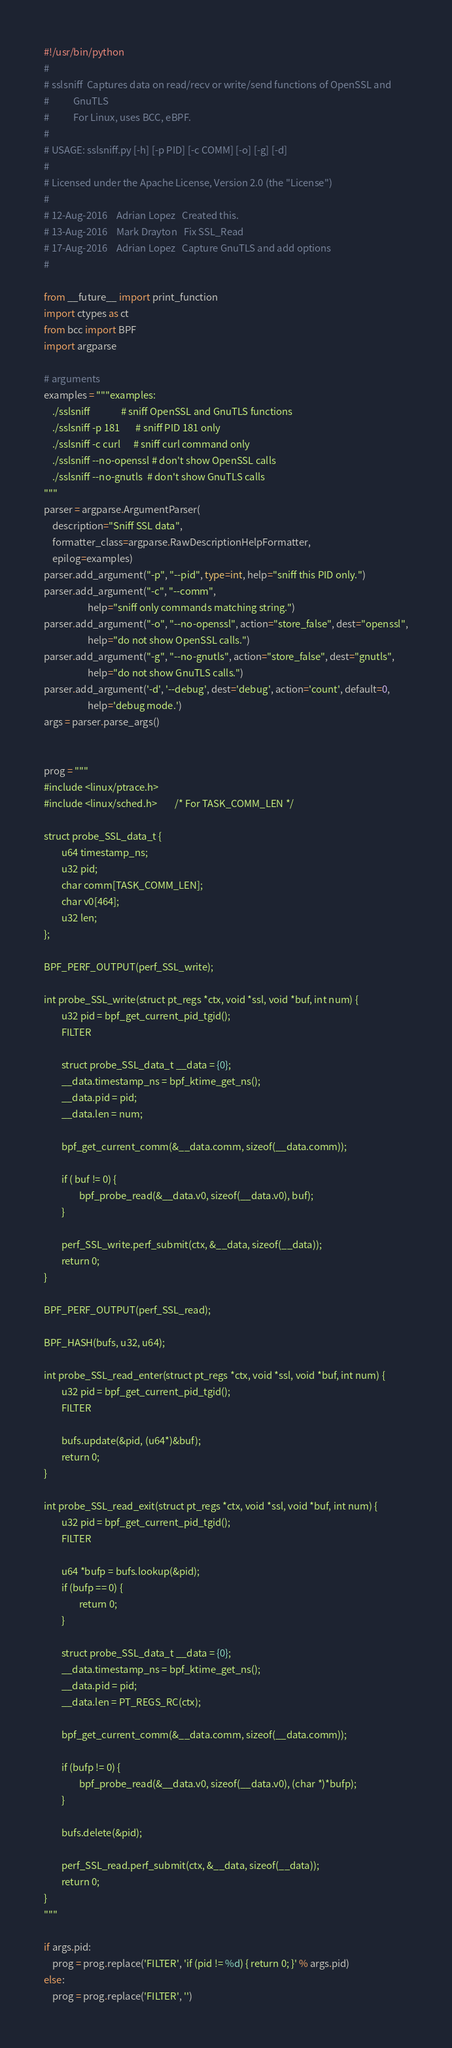<code> <loc_0><loc_0><loc_500><loc_500><_Python_>#!/usr/bin/python
#
# sslsniff  Captures data on read/recv or write/send functions of OpenSSL and
#           GnuTLS
#           For Linux, uses BCC, eBPF.
#
# USAGE: sslsniff.py [-h] [-p PID] [-c COMM] [-o] [-g] [-d]
#
# Licensed under the Apache License, Version 2.0 (the "License")
#
# 12-Aug-2016    Adrian Lopez   Created this.
# 13-Aug-2016    Mark Drayton   Fix SSL_Read
# 17-Aug-2016    Adrian Lopez   Capture GnuTLS and add options
#

from __future__ import print_function
import ctypes as ct
from bcc import BPF
import argparse

# arguments
examples = """examples:
    ./sslsniff              # sniff OpenSSL and GnuTLS functions
    ./sslsniff -p 181       # sniff PID 181 only
    ./sslsniff -c curl      # sniff curl command only
    ./sslsniff --no-openssl # don't show OpenSSL calls
    ./sslsniff --no-gnutls  # don't show GnuTLS calls
"""
parser = argparse.ArgumentParser(
    description="Sniff SSL data",
    formatter_class=argparse.RawDescriptionHelpFormatter,
    epilog=examples)
parser.add_argument("-p", "--pid", type=int, help="sniff this PID only.")
parser.add_argument("-c", "--comm",
                    help="sniff only commands matching string.")
parser.add_argument("-o", "--no-openssl", action="store_false", dest="openssl",
                    help="do not show OpenSSL calls.")
parser.add_argument("-g", "--no-gnutls", action="store_false", dest="gnutls",
                    help="do not show GnuTLS calls.")
parser.add_argument('-d', '--debug', dest='debug', action='count', default=0,
                    help='debug mode.')
args = parser.parse_args()


prog = """
#include <linux/ptrace.h>
#include <linux/sched.h>        /* For TASK_COMM_LEN */

struct probe_SSL_data_t {
        u64 timestamp_ns;
        u32 pid;
        char comm[TASK_COMM_LEN];
        char v0[464];
        u32 len;
};

BPF_PERF_OUTPUT(perf_SSL_write);

int probe_SSL_write(struct pt_regs *ctx, void *ssl, void *buf, int num) {
        u32 pid = bpf_get_current_pid_tgid();
        FILTER

        struct probe_SSL_data_t __data = {0};
        __data.timestamp_ns = bpf_ktime_get_ns();
        __data.pid = pid;
        __data.len = num;

        bpf_get_current_comm(&__data.comm, sizeof(__data.comm));

        if ( buf != 0) {
                bpf_probe_read(&__data.v0, sizeof(__data.v0), buf);
        }

        perf_SSL_write.perf_submit(ctx, &__data, sizeof(__data));
        return 0;
}

BPF_PERF_OUTPUT(perf_SSL_read);

BPF_HASH(bufs, u32, u64);

int probe_SSL_read_enter(struct pt_regs *ctx, void *ssl, void *buf, int num) {
        u32 pid = bpf_get_current_pid_tgid();
        FILTER

        bufs.update(&pid, (u64*)&buf);
        return 0;
}

int probe_SSL_read_exit(struct pt_regs *ctx, void *ssl, void *buf, int num) {
        u32 pid = bpf_get_current_pid_tgid();
        FILTER

        u64 *bufp = bufs.lookup(&pid);
        if (bufp == 0) {
                return 0;
        }

        struct probe_SSL_data_t __data = {0};
        __data.timestamp_ns = bpf_ktime_get_ns();
        __data.pid = pid;
        __data.len = PT_REGS_RC(ctx);

        bpf_get_current_comm(&__data.comm, sizeof(__data.comm));

        if (bufp != 0) {
                bpf_probe_read(&__data.v0, sizeof(__data.v0), (char *)*bufp);
        }

        bufs.delete(&pid);

        perf_SSL_read.perf_submit(ctx, &__data, sizeof(__data));
        return 0;
}
"""

if args.pid:
    prog = prog.replace('FILTER', 'if (pid != %d) { return 0; }' % args.pid)
else:
    prog = prog.replace('FILTER', '')
</code> 